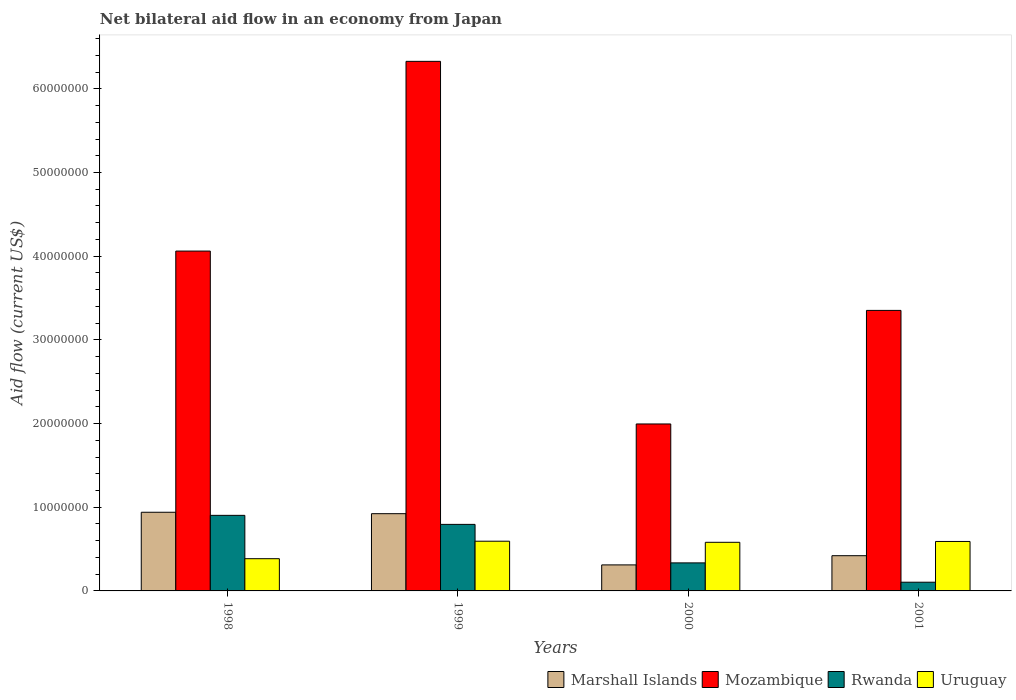How many different coloured bars are there?
Your answer should be compact. 4. How many groups of bars are there?
Your answer should be very brief. 4. Are the number of bars on each tick of the X-axis equal?
Your answer should be very brief. Yes. How many bars are there on the 1st tick from the right?
Offer a terse response. 4. What is the label of the 3rd group of bars from the left?
Make the answer very short. 2000. In how many cases, is the number of bars for a given year not equal to the number of legend labels?
Provide a succinct answer. 0. What is the net bilateral aid flow in Mozambique in 2001?
Your answer should be very brief. 3.35e+07. Across all years, what is the maximum net bilateral aid flow in Marshall Islands?
Keep it short and to the point. 9.40e+06. Across all years, what is the minimum net bilateral aid flow in Uruguay?
Keep it short and to the point. 3.85e+06. In which year was the net bilateral aid flow in Marshall Islands maximum?
Ensure brevity in your answer.  1998. What is the total net bilateral aid flow in Uruguay in the graph?
Your answer should be compact. 2.15e+07. What is the difference between the net bilateral aid flow in Rwanda in 1998 and that in 2000?
Your answer should be compact. 5.68e+06. What is the difference between the net bilateral aid flow in Uruguay in 1998 and the net bilateral aid flow in Rwanda in 2001?
Offer a very short reply. 2.81e+06. What is the average net bilateral aid flow in Rwanda per year?
Offer a terse response. 5.34e+06. In the year 1999, what is the difference between the net bilateral aid flow in Uruguay and net bilateral aid flow in Rwanda?
Your response must be concise. -2.01e+06. In how many years, is the net bilateral aid flow in Mozambique greater than 44000000 US$?
Offer a terse response. 1. What is the ratio of the net bilateral aid flow in Marshall Islands in 1998 to that in 2000?
Provide a succinct answer. 3.02. Is the difference between the net bilateral aid flow in Uruguay in 1998 and 2000 greater than the difference between the net bilateral aid flow in Rwanda in 1998 and 2000?
Give a very brief answer. No. What is the difference between the highest and the second highest net bilateral aid flow in Rwanda?
Provide a succinct answer. 1.08e+06. What is the difference between the highest and the lowest net bilateral aid flow in Rwanda?
Make the answer very short. 7.99e+06. What does the 3rd bar from the left in 2001 represents?
Your answer should be very brief. Rwanda. What does the 4th bar from the right in 1999 represents?
Provide a short and direct response. Marshall Islands. Are all the bars in the graph horizontal?
Your answer should be very brief. No. How many years are there in the graph?
Offer a very short reply. 4. Does the graph contain any zero values?
Provide a short and direct response. No. What is the title of the graph?
Your response must be concise. Net bilateral aid flow in an economy from Japan. Does "Nigeria" appear as one of the legend labels in the graph?
Offer a very short reply. No. What is the label or title of the X-axis?
Your response must be concise. Years. What is the Aid flow (current US$) in Marshall Islands in 1998?
Your response must be concise. 9.40e+06. What is the Aid flow (current US$) of Mozambique in 1998?
Provide a succinct answer. 4.06e+07. What is the Aid flow (current US$) in Rwanda in 1998?
Your answer should be compact. 9.03e+06. What is the Aid flow (current US$) of Uruguay in 1998?
Offer a terse response. 3.85e+06. What is the Aid flow (current US$) of Marshall Islands in 1999?
Your answer should be very brief. 9.23e+06. What is the Aid flow (current US$) in Mozambique in 1999?
Provide a succinct answer. 6.33e+07. What is the Aid flow (current US$) in Rwanda in 1999?
Offer a terse response. 7.95e+06. What is the Aid flow (current US$) in Uruguay in 1999?
Keep it short and to the point. 5.94e+06. What is the Aid flow (current US$) in Marshall Islands in 2000?
Your response must be concise. 3.11e+06. What is the Aid flow (current US$) in Mozambique in 2000?
Provide a succinct answer. 2.00e+07. What is the Aid flow (current US$) of Rwanda in 2000?
Make the answer very short. 3.35e+06. What is the Aid flow (current US$) in Uruguay in 2000?
Offer a very short reply. 5.81e+06. What is the Aid flow (current US$) in Marshall Islands in 2001?
Ensure brevity in your answer.  4.21e+06. What is the Aid flow (current US$) in Mozambique in 2001?
Provide a short and direct response. 3.35e+07. What is the Aid flow (current US$) in Rwanda in 2001?
Provide a succinct answer. 1.04e+06. What is the Aid flow (current US$) of Uruguay in 2001?
Your response must be concise. 5.91e+06. Across all years, what is the maximum Aid flow (current US$) of Marshall Islands?
Ensure brevity in your answer.  9.40e+06. Across all years, what is the maximum Aid flow (current US$) in Mozambique?
Make the answer very short. 6.33e+07. Across all years, what is the maximum Aid flow (current US$) of Rwanda?
Make the answer very short. 9.03e+06. Across all years, what is the maximum Aid flow (current US$) of Uruguay?
Your answer should be compact. 5.94e+06. Across all years, what is the minimum Aid flow (current US$) of Marshall Islands?
Your response must be concise. 3.11e+06. Across all years, what is the minimum Aid flow (current US$) in Mozambique?
Keep it short and to the point. 2.00e+07. Across all years, what is the minimum Aid flow (current US$) of Rwanda?
Provide a short and direct response. 1.04e+06. Across all years, what is the minimum Aid flow (current US$) in Uruguay?
Your answer should be compact. 3.85e+06. What is the total Aid flow (current US$) of Marshall Islands in the graph?
Ensure brevity in your answer.  2.60e+07. What is the total Aid flow (current US$) in Mozambique in the graph?
Provide a short and direct response. 1.57e+08. What is the total Aid flow (current US$) in Rwanda in the graph?
Your response must be concise. 2.14e+07. What is the total Aid flow (current US$) of Uruguay in the graph?
Offer a very short reply. 2.15e+07. What is the difference between the Aid flow (current US$) of Mozambique in 1998 and that in 1999?
Your answer should be compact. -2.27e+07. What is the difference between the Aid flow (current US$) in Rwanda in 1998 and that in 1999?
Offer a terse response. 1.08e+06. What is the difference between the Aid flow (current US$) in Uruguay in 1998 and that in 1999?
Ensure brevity in your answer.  -2.09e+06. What is the difference between the Aid flow (current US$) in Marshall Islands in 1998 and that in 2000?
Your answer should be compact. 6.29e+06. What is the difference between the Aid flow (current US$) of Mozambique in 1998 and that in 2000?
Your answer should be very brief. 2.07e+07. What is the difference between the Aid flow (current US$) in Rwanda in 1998 and that in 2000?
Offer a terse response. 5.68e+06. What is the difference between the Aid flow (current US$) in Uruguay in 1998 and that in 2000?
Provide a short and direct response. -1.96e+06. What is the difference between the Aid flow (current US$) of Marshall Islands in 1998 and that in 2001?
Offer a terse response. 5.19e+06. What is the difference between the Aid flow (current US$) of Mozambique in 1998 and that in 2001?
Provide a short and direct response. 7.09e+06. What is the difference between the Aid flow (current US$) of Rwanda in 1998 and that in 2001?
Your response must be concise. 7.99e+06. What is the difference between the Aid flow (current US$) in Uruguay in 1998 and that in 2001?
Your answer should be compact. -2.06e+06. What is the difference between the Aid flow (current US$) in Marshall Islands in 1999 and that in 2000?
Ensure brevity in your answer.  6.12e+06. What is the difference between the Aid flow (current US$) in Mozambique in 1999 and that in 2000?
Your answer should be compact. 4.33e+07. What is the difference between the Aid flow (current US$) in Rwanda in 1999 and that in 2000?
Your answer should be very brief. 4.60e+06. What is the difference between the Aid flow (current US$) in Marshall Islands in 1999 and that in 2001?
Provide a succinct answer. 5.02e+06. What is the difference between the Aid flow (current US$) in Mozambique in 1999 and that in 2001?
Offer a very short reply. 2.98e+07. What is the difference between the Aid flow (current US$) of Rwanda in 1999 and that in 2001?
Provide a succinct answer. 6.91e+06. What is the difference between the Aid flow (current US$) in Uruguay in 1999 and that in 2001?
Give a very brief answer. 3.00e+04. What is the difference between the Aid flow (current US$) in Marshall Islands in 2000 and that in 2001?
Your response must be concise. -1.10e+06. What is the difference between the Aid flow (current US$) of Mozambique in 2000 and that in 2001?
Provide a succinct answer. -1.36e+07. What is the difference between the Aid flow (current US$) in Rwanda in 2000 and that in 2001?
Your answer should be compact. 2.31e+06. What is the difference between the Aid flow (current US$) of Uruguay in 2000 and that in 2001?
Provide a short and direct response. -1.00e+05. What is the difference between the Aid flow (current US$) in Marshall Islands in 1998 and the Aid flow (current US$) in Mozambique in 1999?
Your answer should be compact. -5.39e+07. What is the difference between the Aid flow (current US$) of Marshall Islands in 1998 and the Aid flow (current US$) of Rwanda in 1999?
Make the answer very short. 1.45e+06. What is the difference between the Aid flow (current US$) in Marshall Islands in 1998 and the Aid flow (current US$) in Uruguay in 1999?
Ensure brevity in your answer.  3.46e+06. What is the difference between the Aid flow (current US$) of Mozambique in 1998 and the Aid flow (current US$) of Rwanda in 1999?
Offer a very short reply. 3.27e+07. What is the difference between the Aid flow (current US$) in Mozambique in 1998 and the Aid flow (current US$) in Uruguay in 1999?
Keep it short and to the point. 3.47e+07. What is the difference between the Aid flow (current US$) in Rwanda in 1998 and the Aid flow (current US$) in Uruguay in 1999?
Make the answer very short. 3.09e+06. What is the difference between the Aid flow (current US$) in Marshall Islands in 1998 and the Aid flow (current US$) in Mozambique in 2000?
Your response must be concise. -1.06e+07. What is the difference between the Aid flow (current US$) of Marshall Islands in 1998 and the Aid flow (current US$) of Rwanda in 2000?
Your answer should be very brief. 6.05e+06. What is the difference between the Aid flow (current US$) of Marshall Islands in 1998 and the Aid flow (current US$) of Uruguay in 2000?
Your answer should be very brief. 3.59e+06. What is the difference between the Aid flow (current US$) in Mozambique in 1998 and the Aid flow (current US$) in Rwanda in 2000?
Your answer should be compact. 3.73e+07. What is the difference between the Aid flow (current US$) of Mozambique in 1998 and the Aid flow (current US$) of Uruguay in 2000?
Your response must be concise. 3.48e+07. What is the difference between the Aid flow (current US$) of Rwanda in 1998 and the Aid flow (current US$) of Uruguay in 2000?
Keep it short and to the point. 3.22e+06. What is the difference between the Aid flow (current US$) of Marshall Islands in 1998 and the Aid flow (current US$) of Mozambique in 2001?
Ensure brevity in your answer.  -2.41e+07. What is the difference between the Aid flow (current US$) in Marshall Islands in 1998 and the Aid flow (current US$) in Rwanda in 2001?
Your response must be concise. 8.36e+06. What is the difference between the Aid flow (current US$) of Marshall Islands in 1998 and the Aid flow (current US$) of Uruguay in 2001?
Ensure brevity in your answer.  3.49e+06. What is the difference between the Aid flow (current US$) of Mozambique in 1998 and the Aid flow (current US$) of Rwanda in 2001?
Ensure brevity in your answer.  3.96e+07. What is the difference between the Aid flow (current US$) of Mozambique in 1998 and the Aid flow (current US$) of Uruguay in 2001?
Your answer should be compact. 3.47e+07. What is the difference between the Aid flow (current US$) of Rwanda in 1998 and the Aid flow (current US$) of Uruguay in 2001?
Make the answer very short. 3.12e+06. What is the difference between the Aid flow (current US$) in Marshall Islands in 1999 and the Aid flow (current US$) in Mozambique in 2000?
Ensure brevity in your answer.  -1.07e+07. What is the difference between the Aid flow (current US$) in Marshall Islands in 1999 and the Aid flow (current US$) in Rwanda in 2000?
Ensure brevity in your answer.  5.88e+06. What is the difference between the Aid flow (current US$) of Marshall Islands in 1999 and the Aid flow (current US$) of Uruguay in 2000?
Provide a short and direct response. 3.42e+06. What is the difference between the Aid flow (current US$) of Mozambique in 1999 and the Aid flow (current US$) of Rwanda in 2000?
Your answer should be compact. 5.99e+07. What is the difference between the Aid flow (current US$) in Mozambique in 1999 and the Aid flow (current US$) in Uruguay in 2000?
Your answer should be very brief. 5.75e+07. What is the difference between the Aid flow (current US$) of Rwanda in 1999 and the Aid flow (current US$) of Uruguay in 2000?
Give a very brief answer. 2.14e+06. What is the difference between the Aid flow (current US$) of Marshall Islands in 1999 and the Aid flow (current US$) of Mozambique in 2001?
Give a very brief answer. -2.43e+07. What is the difference between the Aid flow (current US$) of Marshall Islands in 1999 and the Aid flow (current US$) of Rwanda in 2001?
Keep it short and to the point. 8.19e+06. What is the difference between the Aid flow (current US$) of Marshall Islands in 1999 and the Aid flow (current US$) of Uruguay in 2001?
Give a very brief answer. 3.32e+06. What is the difference between the Aid flow (current US$) in Mozambique in 1999 and the Aid flow (current US$) in Rwanda in 2001?
Offer a very short reply. 6.22e+07. What is the difference between the Aid flow (current US$) in Mozambique in 1999 and the Aid flow (current US$) in Uruguay in 2001?
Provide a succinct answer. 5.74e+07. What is the difference between the Aid flow (current US$) in Rwanda in 1999 and the Aid flow (current US$) in Uruguay in 2001?
Offer a terse response. 2.04e+06. What is the difference between the Aid flow (current US$) in Marshall Islands in 2000 and the Aid flow (current US$) in Mozambique in 2001?
Your answer should be very brief. -3.04e+07. What is the difference between the Aid flow (current US$) in Marshall Islands in 2000 and the Aid flow (current US$) in Rwanda in 2001?
Your response must be concise. 2.07e+06. What is the difference between the Aid flow (current US$) in Marshall Islands in 2000 and the Aid flow (current US$) in Uruguay in 2001?
Offer a very short reply. -2.80e+06. What is the difference between the Aid flow (current US$) in Mozambique in 2000 and the Aid flow (current US$) in Rwanda in 2001?
Ensure brevity in your answer.  1.89e+07. What is the difference between the Aid flow (current US$) of Mozambique in 2000 and the Aid flow (current US$) of Uruguay in 2001?
Make the answer very short. 1.40e+07. What is the difference between the Aid flow (current US$) of Rwanda in 2000 and the Aid flow (current US$) of Uruguay in 2001?
Give a very brief answer. -2.56e+06. What is the average Aid flow (current US$) of Marshall Islands per year?
Provide a short and direct response. 6.49e+06. What is the average Aid flow (current US$) of Mozambique per year?
Provide a succinct answer. 3.93e+07. What is the average Aid flow (current US$) of Rwanda per year?
Provide a succinct answer. 5.34e+06. What is the average Aid flow (current US$) in Uruguay per year?
Offer a terse response. 5.38e+06. In the year 1998, what is the difference between the Aid flow (current US$) of Marshall Islands and Aid flow (current US$) of Mozambique?
Keep it short and to the point. -3.12e+07. In the year 1998, what is the difference between the Aid flow (current US$) in Marshall Islands and Aid flow (current US$) in Rwanda?
Your answer should be compact. 3.70e+05. In the year 1998, what is the difference between the Aid flow (current US$) of Marshall Islands and Aid flow (current US$) of Uruguay?
Keep it short and to the point. 5.55e+06. In the year 1998, what is the difference between the Aid flow (current US$) in Mozambique and Aid flow (current US$) in Rwanda?
Offer a terse response. 3.16e+07. In the year 1998, what is the difference between the Aid flow (current US$) of Mozambique and Aid flow (current US$) of Uruguay?
Your answer should be compact. 3.68e+07. In the year 1998, what is the difference between the Aid flow (current US$) of Rwanda and Aid flow (current US$) of Uruguay?
Ensure brevity in your answer.  5.18e+06. In the year 1999, what is the difference between the Aid flow (current US$) in Marshall Islands and Aid flow (current US$) in Mozambique?
Your answer should be compact. -5.40e+07. In the year 1999, what is the difference between the Aid flow (current US$) of Marshall Islands and Aid flow (current US$) of Rwanda?
Your response must be concise. 1.28e+06. In the year 1999, what is the difference between the Aid flow (current US$) of Marshall Islands and Aid flow (current US$) of Uruguay?
Keep it short and to the point. 3.29e+06. In the year 1999, what is the difference between the Aid flow (current US$) in Mozambique and Aid flow (current US$) in Rwanda?
Offer a terse response. 5.53e+07. In the year 1999, what is the difference between the Aid flow (current US$) in Mozambique and Aid flow (current US$) in Uruguay?
Offer a very short reply. 5.73e+07. In the year 1999, what is the difference between the Aid flow (current US$) in Rwanda and Aid flow (current US$) in Uruguay?
Offer a terse response. 2.01e+06. In the year 2000, what is the difference between the Aid flow (current US$) in Marshall Islands and Aid flow (current US$) in Mozambique?
Offer a terse response. -1.68e+07. In the year 2000, what is the difference between the Aid flow (current US$) of Marshall Islands and Aid flow (current US$) of Uruguay?
Keep it short and to the point. -2.70e+06. In the year 2000, what is the difference between the Aid flow (current US$) of Mozambique and Aid flow (current US$) of Rwanda?
Ensure brevity in your answer.  1.66e+07. In the year 2000, what is the difference between the Aid flow (current US$) in Mozambique and Aid flow (current US$) in Uruguay?
Keep it short and to the point. 1.41e+07. In the year 2000, what is the difference between the Aid flow (current US$) in Rwanda and Aid flow (current US$) in Uruguay?
Keep it short and to the point. -2.46e+06. In the year 2001, what is the difference between the Aid flow (current US$) in Marshall Islands and Aid flow (current US$) in Mozambique?
Your response must be concise. -2.93e+07. In the year 2001, what is the difference between the Aid flow (current US$) in Marshall Islands and Aid flow (current US$) in Rwanda?
Offer a terse response. 3.17e+06. In the year 2001, what is the difference between the Aid flow (current US$) in Marshall Islands and Aid flow (current US$) in Uruguay?
Offer a very short reply. -1.70e+06. In the year 2001, what is the difference between the Aid flow (current US$) of Mozambique and Aid flow (current US$) of Rwanda?
Ensure brevity in your answer.  3.25e+07. In the year 2001, what is the difference between the Aid flow (current US$) in Mozambique and Aid flow (current US$) in Uruguay?
Offer a very short reply. 2.76e+07. In the year 2001, what is the difference between the Aid flow (current US$) in Rwanda and Aid flow (current US$) in Uruguay?
Ensure brevity in your answer.  -4.87e+06. What is the ratio of the Aid flow (current US$) in Marshall Islands in 1998 to that in 1999?
Make the answer very short. 1.02. What is the ratio of the Aid flow (current US$) in Mozambique in 1998 to that in 1999?
Your answer should be compact. 0.64. What is the ratio of the Aid flow (current US$) of Rwanda in 1998 to that in 1999?
Offer a very short reply. 1.14. What is the ratio of the Aid flow (current US$) in Uruguay in 1998 to that in 1999?
Offer a terse response. 0.65. What is the ratio of the Aid flow (current US$) of Marshall Islands in 1998 to that in 2000?
Ensure brevity in your answer.  3.02. What is the ratio of the Aid flow (current US$) in Mozambique in 1998 to that in 2000?
Offer a terse response. 2.04. What is the ratio of the Aid flow (current US$) of Rwanda in 1998 to that in 2000?
Offer a very short reply. 2.7. What is the ratio of the Aid flow (current US$) in Uruguay in 1998 to that in 2000?
Keep it short and to the point. 0.66. What is the ratio of the Aid flow (current US$) in Marshall Islands in 1998 to that in 2001?
Offer a terse response. 2.23. What is the ratio of the Aid flow (current US$) of Mozambique in 1998 to that in 2001?
Offer a very short reply. 1.21. What is the ratio of the Aid flow (current US$) in Rwanda in 1998 to that in 2001?
Your answer should be very brief. 8.68. What is the ratio of the Aid flow (current US$) of Uruguay in 1998 to that in 2001?
Keep it short and to the point. 0.65. What is the ratio of the Aid flow (current US$) in Marshall Islands in 1999 to that in 2000?
Your answer should be compact. 2.97. What is the ratio of the Aid flow (current US$) of Mozambique in 1999 to that in 2000?
Your answer should be very brief. 3.17. What is the ratio of the Aid flow (current US$) in Rwanda in 1999 to that in 2000?
Offer a very short reply. 2.37. What is the ratio of the Aid flow (current US$) of Uruguay in 1999 to that in 2000?
Keep it short and to the point. 1.02. What is the ratio of the Aid flow (current US$) in Marshall Islands in 1999 to that in 2001?
Keep it short and to the point. 2.19. What is the ratio of the Aid flow (current US$) of Mozambique in 1999 to that in 2001?
Offer a very short reply. 1.89. What is the ratio of the Aid flow (current US$) in Rwanda in 1999 to that in 2001?
Offer a terse response. 7.64. What is the ratio of the Aid flow (current US$) of Marshall Islands in 2000 to that in 2001?
Keep it short and to the point. 0.74. What is the ratio of the Aid flow (current US$) in Mozambique in 2000 to that in 2001?
Keep it short and to the point. 0.6. What is the ratio of the Aid flow (current US$) of Rwanda in 2000 to that in 2001?
Your answer should be very brief. 3.22. What is the ratio of the Aid flow (current US$) of Uruguay in 2000 to that in 2001?
Make the answer very short. 0.98. What is the difference between the highest and the second highest Aid flow (current US$) of Marshall Islands?
Your response must be concise. 1.70e+05. What is the difference between the highest and the second highest Aid flow (current US$) of Mozambique?
Offer a very short reply. 2.27e+07. What is the difference between the highest and the second highest Aid flow (current US$) of Rwanda?
Give a very brief answer. 1.08e+06. What is the difference between the highest and the lowest Aid flow (current US$) of Marshall Islands?
Offer a terse response. 6.29e+06. What is the difference between the highest and the lowest Aid flow (current US$) in Mozambique?
Your answer should be compact. 4.33e+07. What is the difference between the highest and the lowest Aid flow (current US$) of Rwanda?
Provide a succinct answer. 7.99e+06. What is the difference between the highest and the lowest Aid flow (current US$) in Uruguay?
Keep it short and to the point. 2.09e+06. 